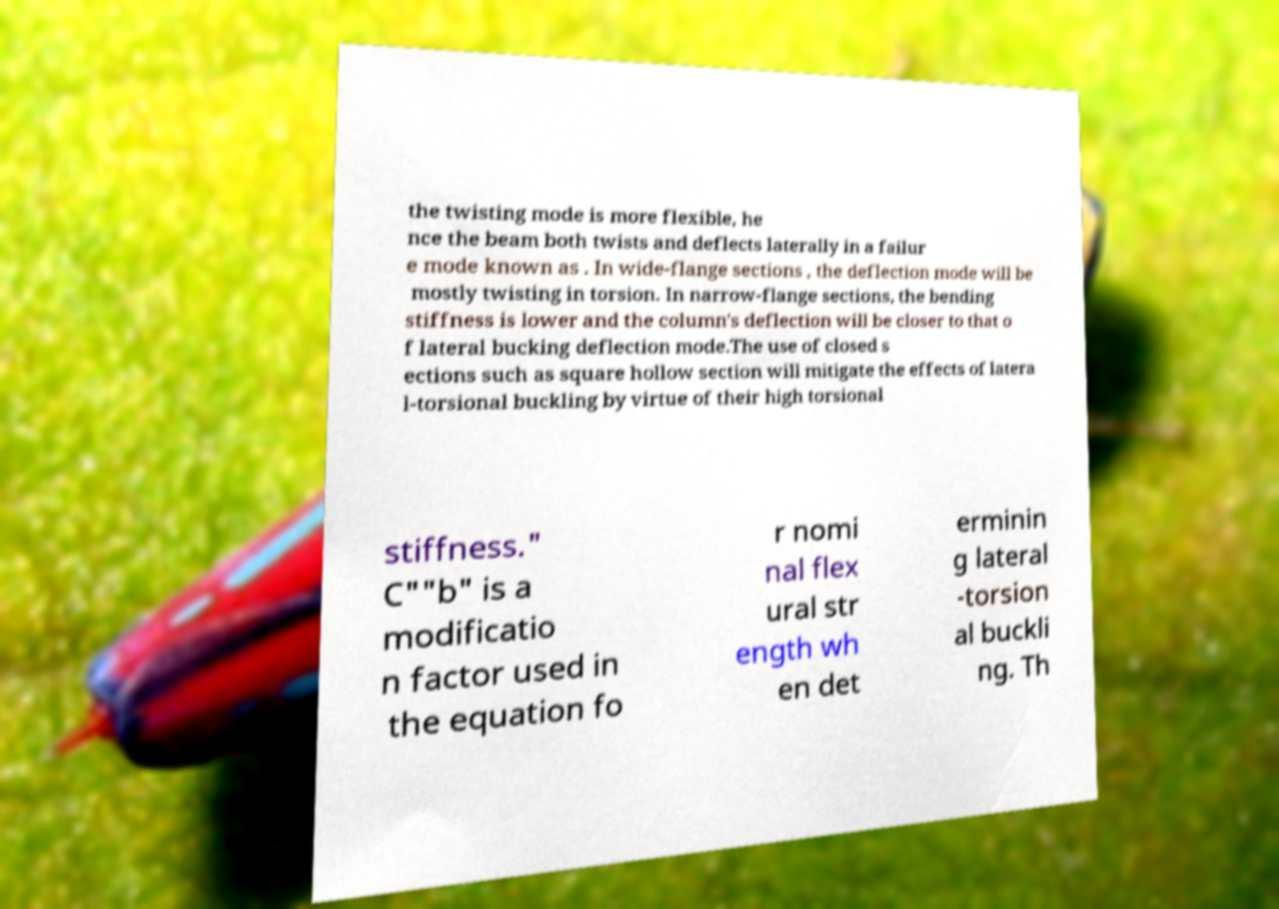Please identify and transcribe the text found in this image. the twisting mode is more flexible, he nce the beam both twists and deflects laterally in a failur e mode known as . In wide-flange sections , the deflection mode will be mostly twisting in torsion. In narrow-flange sections, the bending stiffness is lower and the column's deflection will be closer to that o f lateral bucking deflection mode.The use of closed s ections such as square hollow section will mitigate the effects of latera l-torsional buckling by virtue of their high torsional stiffness." C""b" is a modificatio n factor used in the equation fo r nomi nal flex ural str ength wh en det erminin g lateral -torsion al buckli ng. Th 